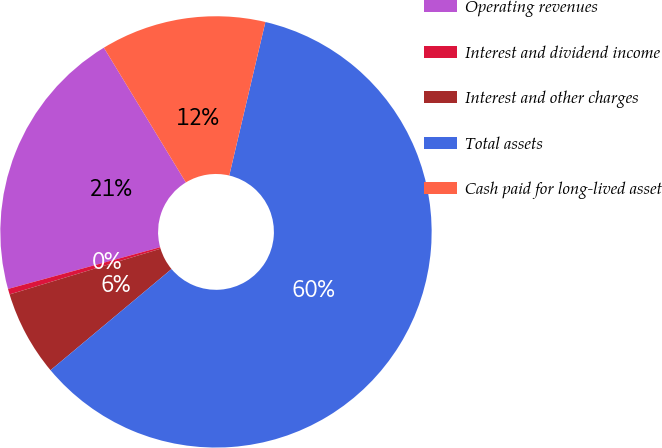Convert chart. <chart><loc_0><loc_0><loc_500><loc_500><pie_chart><fcel>Operating revenues<fcel>Interest and dividend income<fcel>Interest and other charges<fcel>Total assets<fcel>Cash paid for long-lived asset<nl><fcel>20.56%<fcel>0.42%<fcel>6.4%<fcel>60.24%<fcel>12.38%<nl></chart> 